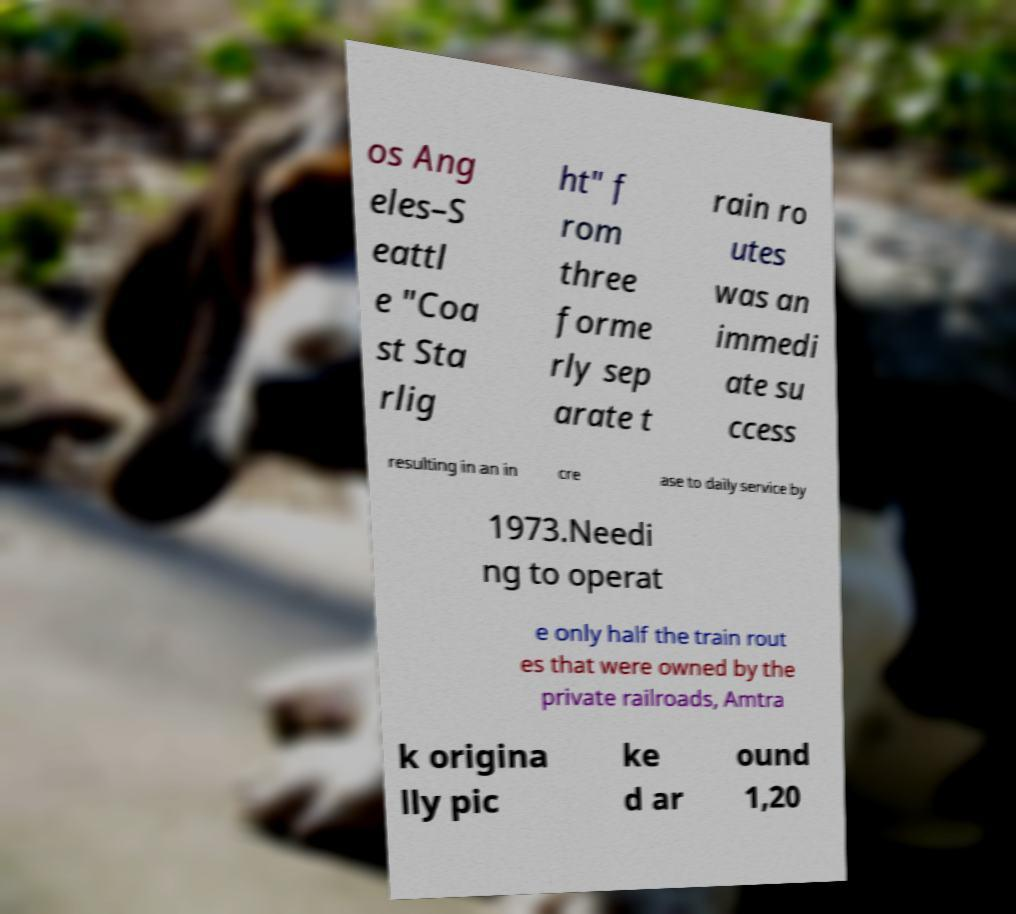Please identify and transcribe the text found in this image. os Ang eles–S eattl e "Coa st Sta rlig ht" f rom three forme rly sep arate t rain ro utes was an immedi ate su ccess resulting in an in cre ase to daily service by 1973.Needi ng to operat e only half the train rout es that were owned by the private railroads, Amtra k origina lly pic ke d ar ound 1,20 